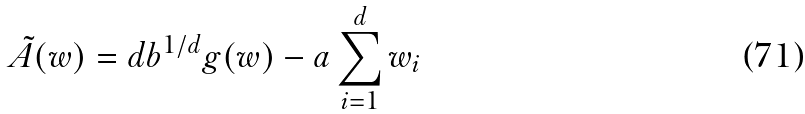<formula> <loc_0><loc_0><loc_500><loc_500>\tilde { A } ( w ) = d b ^ { 1 / d } g ( w ) - a \sum _ { i = 1 } ^ { d } { w _ { i } }</formula> 